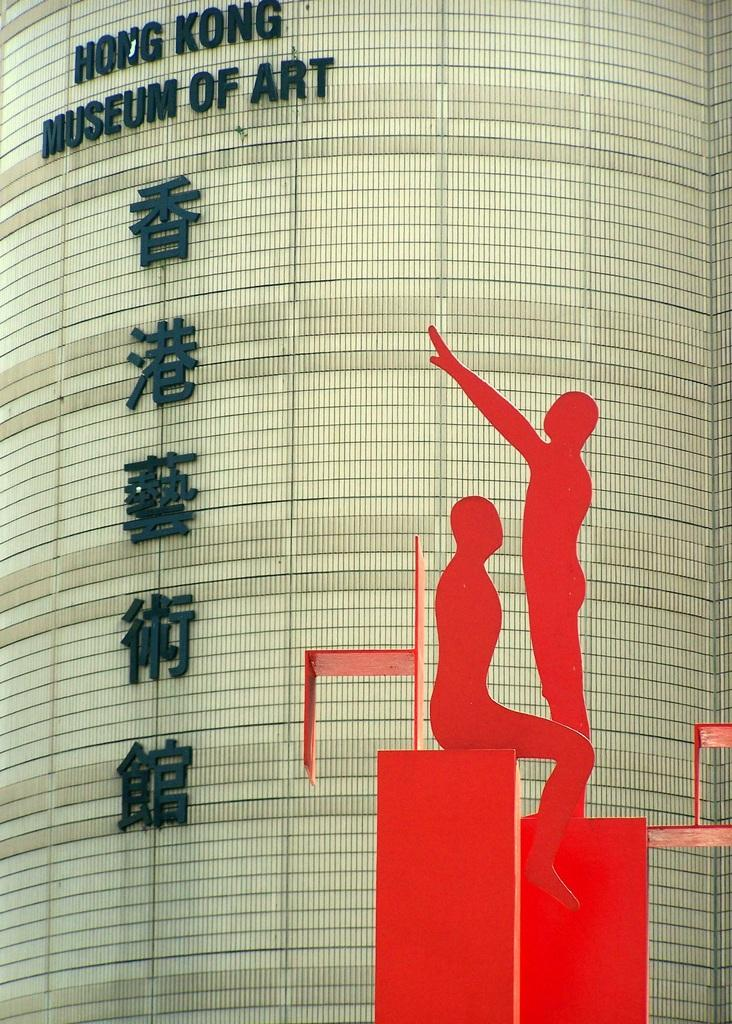What is present on the wall in the image? Something is written on the wall in the image. What can be seen on the right side of the image? There is a red color art on the right side of the image. What are the people in the image doing with the art? A person is sitting on the art, and another person is standing on the art. What is the rate of the form's growth in the image? There is no form or growth rate present in the image; it features a wall with writing, red art, and people interacting with the art. 